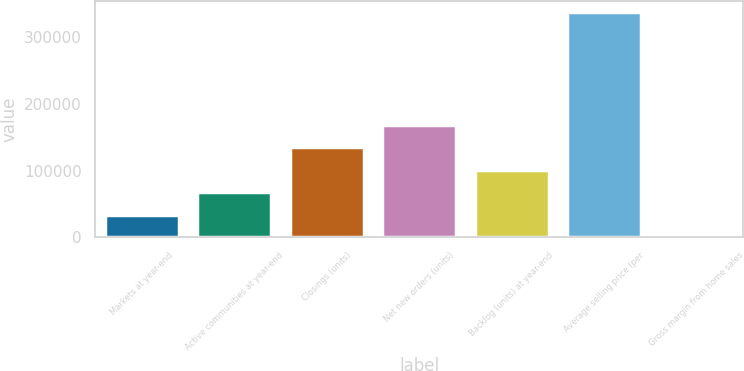Convert chart. <chart><loc_0><loc_0><loc_500><loc_500><bar_chart><fcel>Markets at year-end<fcel>Active communities at year-end<fcel>Closings (units)<fcel>Net new orders (units)<fcel>Backlog (units) at year-end<fcel>Average selling price (per<fcel>Gross margin from home sales<nl><fcel>33824.2<fcel>67621.5<fcel>135216<fcel>169013<fcel>101419<fcel>338000<fcel>26.9<nl></chart> 